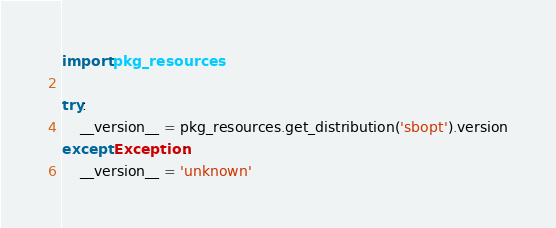<code> <loc_0><loc_0><loc_500><loc_500><_Python_>import pkg_resources

try:
    __version__ = pkg_resources.get_distribution('sbopt').version
except Exception:
    __version__ = 'unknown'
</code> 